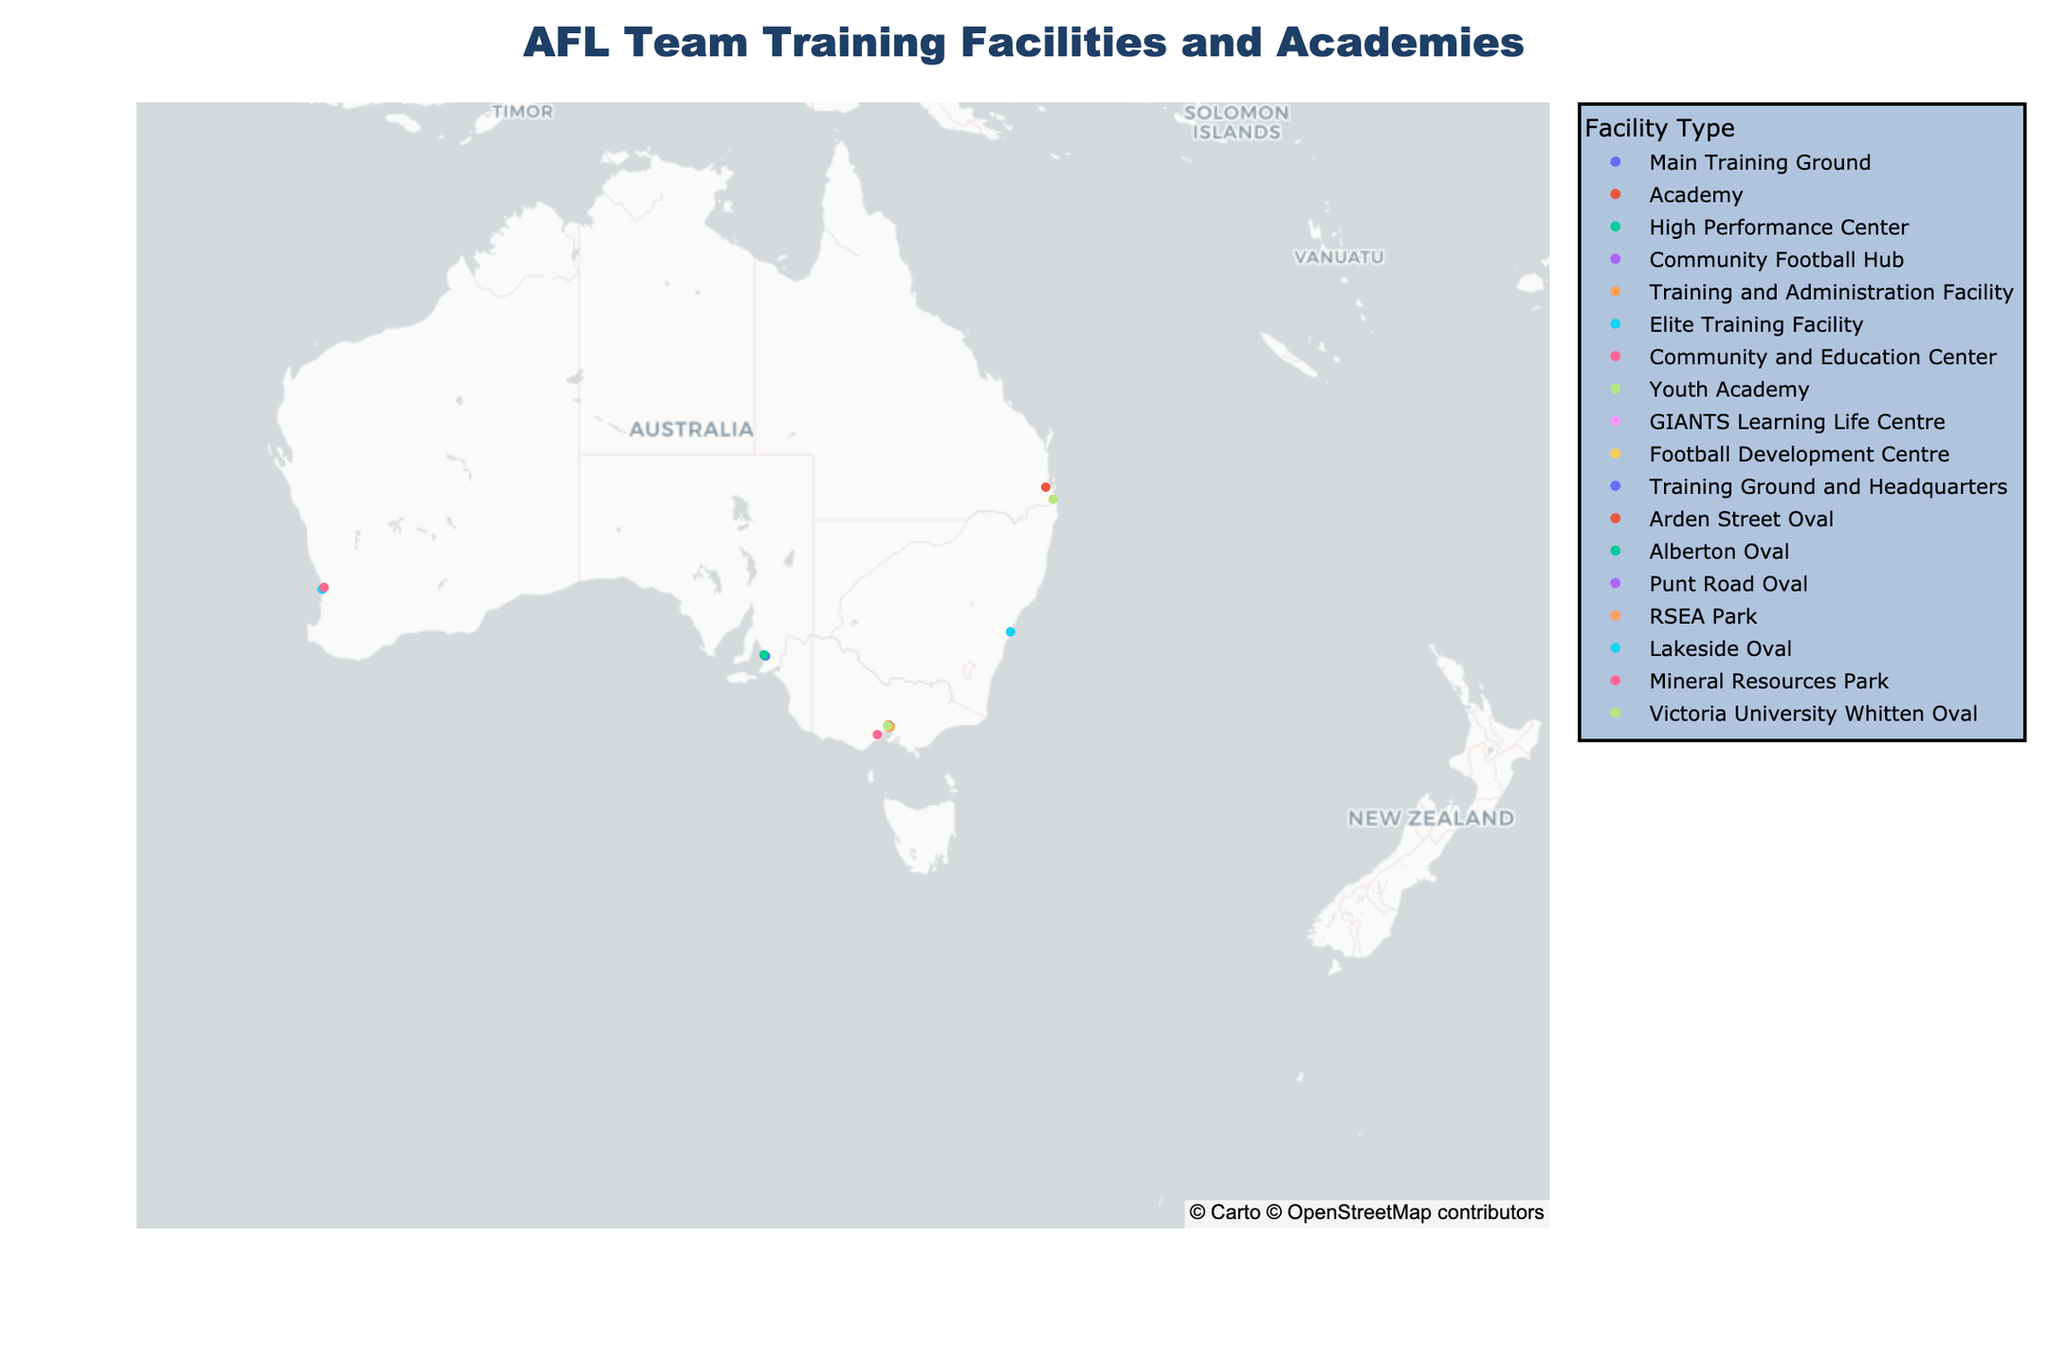What is the title of the plot? The title is prominently displayed at the top center of the plot. It reads "AFL Team Training Facilities and Academies".
Answer: AFL Team Training Facilities and Academies Which city has the highest number of training facilities shown on the map? To determine this, observe the clusters of points on the map. Melbourne has the densest cluster, indicating it has the highest number of training facilities.
Answer: Melbourne Identify the facility type most commonly found in Sydney. By examining the points located around Sydney's coordinates (-33.8688, 151.2093), note the facility types listed in the hover information. Both facilities are listed as "Academies" indicating academies are more common.
Answer: Academies How many training facilities are listed in Perth? Find the points near Perth's coordinates (-31.9505, 115.8605). There is one point which represents the West Coast Eagles.
Answer: 1 What type of facility is indicated for the Fremantle team? Hover over or look at the point near Fremantle's coordinates (-32.0397, 115.7567) to see that it is labeled as an "Elite Training Facility".
Answer: Elite Training Facility Which city has both a Community Football Hub and another type of training facility? Observe the colors and hover information of the points around Melbourne (-37.8136, 144.9631). Melbourne hosts "Collingwood" with a Community Football Hub and "Melbourne" with a Training Ground and Headquarters.
Answer: Melbourne Which team has its training facility furthest towards the west of the map? Look at the point closest to the westernmost edge of the map, which is the West Coast Eagles in Perth (-31.9505, 115.8605).
Answer: West Coast Eagles Compare the facility types between the two Sydney teams: Sydney Swans and Greater Western Sydney. What are their facility types? The geographical points for Sydney teams are at coordinates (-33.8688, 151.2093). One is marked as a "Lakeside Oval" for the Sydney Swans and the other as "GIANTS Learning Life Centre" for Greater Western Sydney.
Answer: Lakeside Oval and GIANTS Learning Life Centre What is the distribution of facility types for teams located in Melbourne? By examining Melbourne's cluster, which includes teams like Carlton, Collingwood, Essendon, etc., you can list the facility types: High Performance Center, Community Football Hub, Training and Administration Facility, Football Development Centre, Arden Street Oval, Punt Road Oval, RSEA Park, and Training Ground and Headquarters.
Answer: Multiple types including High Performance Center, Community Football Hub, etc Which state or territory appears to have the fewest number of facilities? Assess the map for areas with the least number of points. The Northern Territory and Tasmania have no points, indicating they have the fewest or no facilities listed.
Answer: Northern Territory and Tasmania 